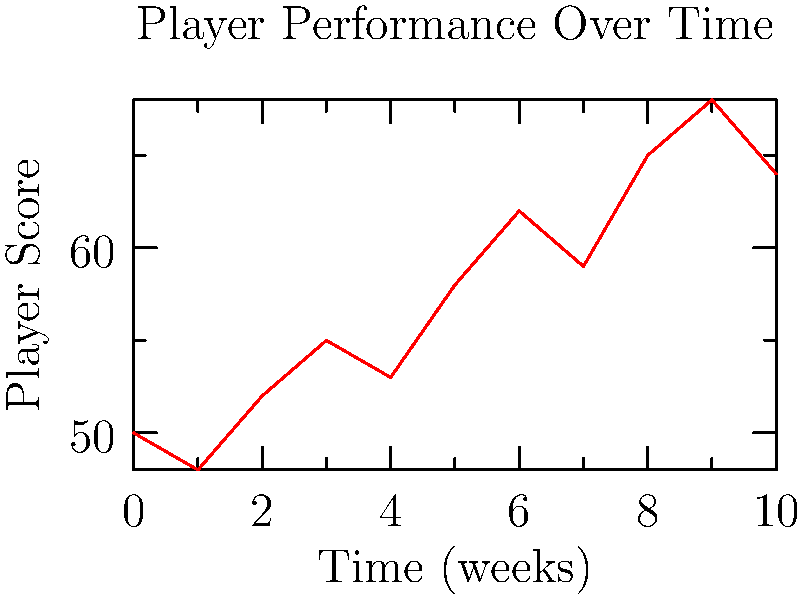In the graph showing a player's performance over time, what is the overall trend of the player's score from week 0 to week 10, despite the occasional dips? To determine the overall trend of the player's score, we need to analyze the graph from start to finish:

1. Start point (week 0): The player's score is 50.
2. End point (week 10): The player's score is 64.
3. Observe the general direction of the line:
   - Despite some ups and downs, the line generally moves upward from left to right.
4. Compare start and end points:
   - The final score (64) is higher than the initial score (50).
5. Analyze the pattern between weeks:
   - There are occasional dips (e.g., weeks 1, 4, 7, 10).
   - However, these dips are followed by rebounds to higher scores.
6. Calculate the overall change:
   - Total change = Final score - Initial score
   - Total change = 64 - 50 = 14 point increase

Despite the fluctuations, the player's score shows an overall increase from week 0 to week 10, indicating an upward trend in performance.
Answer: Upward trend 